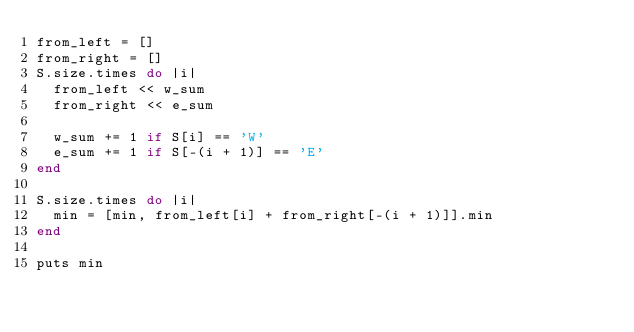Convert code to text. <code><loc_0><loc_0><loc_500><loc_500><_Ruby_>from_left = []
from_right = []
S.size.times do |i|
  from_left << w_sum
  from_right << e_sum

  w_sum += 1 if S[i] == 'W'
  e_sum += 1 if S[-(i + 1)] == 'E'
end

S.size.times do |i|
  min = [min, from_left[i] + from_right[-(i + 1)]].min
end

puts min</code> 